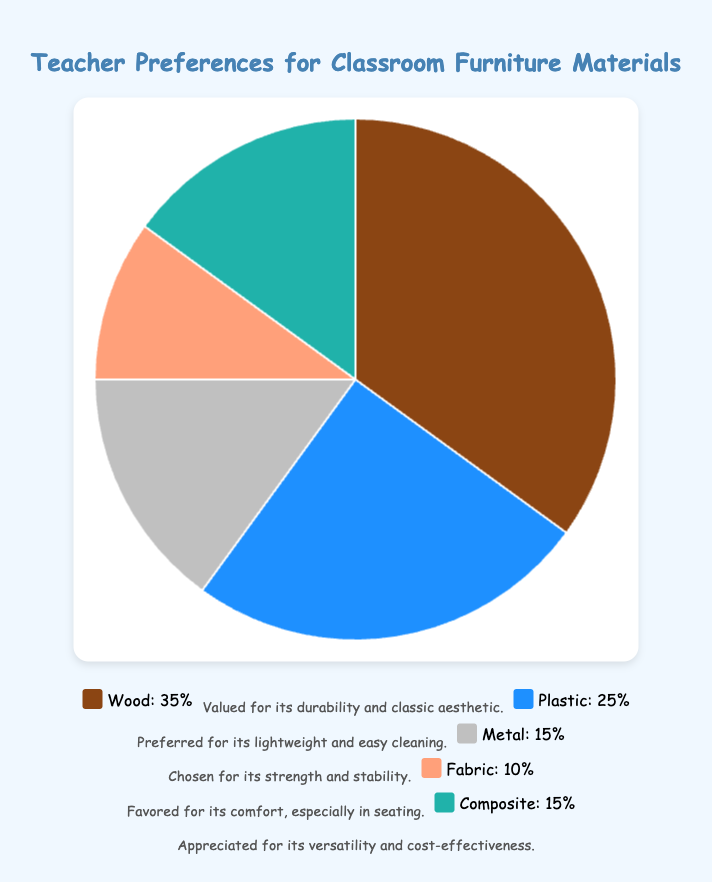Which material is preferred by the most teachers? Wood is preferred by the most teachers, which can be seen from the largest slice in the pie chart representing 35% of the total responses.
Answer: Wood Which two materials are equally preferred by teachers? Both Metal and Composite are equally preferred by teachers, each making up 15% of the total responses, as indicated by the similarly sized slices in the pie chart.
Answer: Metal, Composite Which material is least preferred by teachers? Fabric is the least preferred material, covering only 10% of the total responses, identifiable by the smallest slice in the pie chart.
Answer: Fabric What percentage of teachers prefer either Wood or Plastic materials? The percentage of teachers who prefer Wood is 35%, and for Plastic, it's 25%. Adding these percentages together gives 35% + 25% = 60%.
Answer: 60% By how much does the preference for Wood exceed the preference for Metal? The preference for Wood is 35%, while the preference for Metal is 15%. The excess is calculated as 35% - 15% = 20%.
Answer: 20% How much more preferred is Plastic compared to Fabric? Plastic is preferred by 25% of teachers, whereas Fabric is preferred by 10%. The difference in preference is 25% - 10% = 15%.
Answer: 15% What is the combined percentage of teachers who prefer Metal and Composite? The preference for Metal is 15%, and for Composite, it's also 15%. Combining these gives 15% + 15% = 30%.
Answer: 30% Which material's color box is light blue in the legend? The light blue color box in the legend represents Composite, as indicated by its color in the pie chart and the legend.
Answer: Composite What is the average percentage preference for all the materials? Adding the percentages: 35% (Wood) + 25% (Plastic) + 15% (Metal) + 10% (Fabric) + 15% (Composite) gives a total of 100%. The average is 100% / 5 = 20%.
Answer: 20% Which material is represented by the brown color in the chart? The brown color in the chart corresponds to Wood, identifiable through its visual representation and the legend.
Answer: Wood 